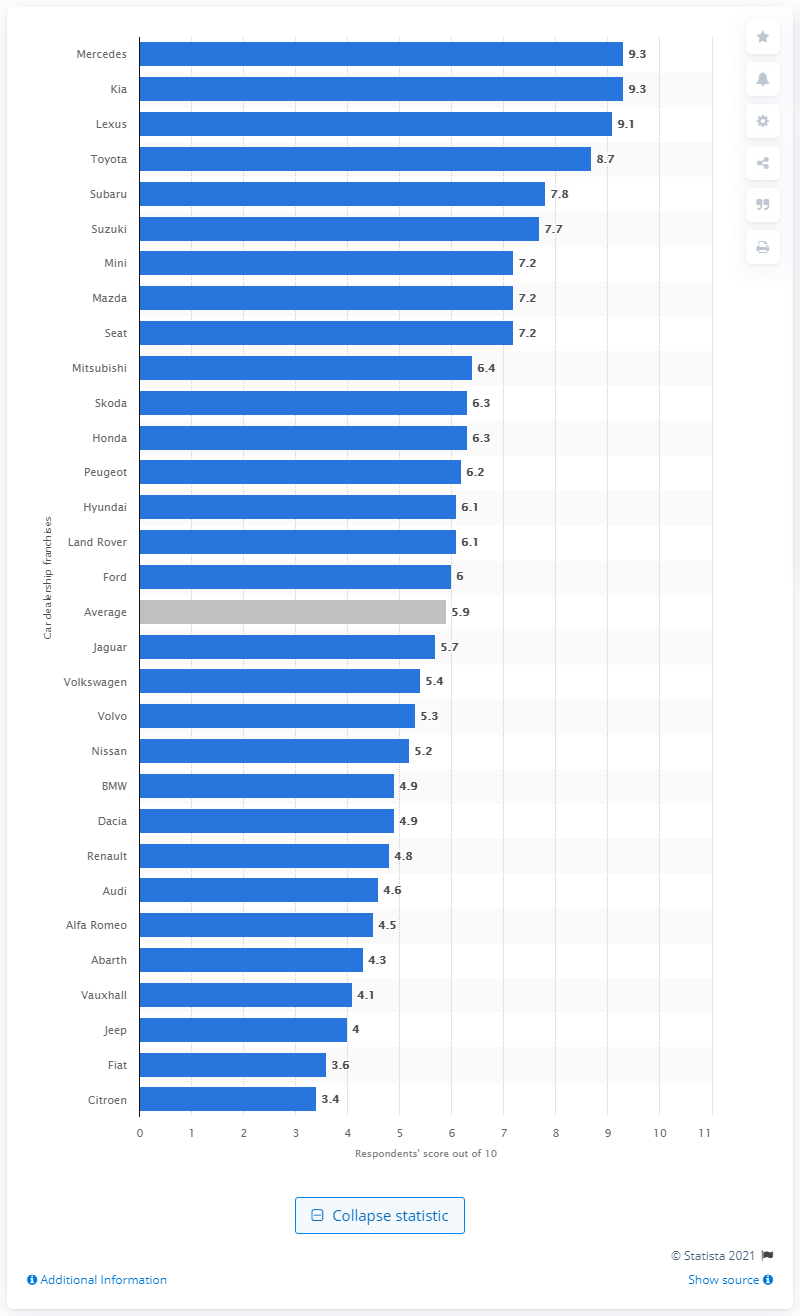Outline some significant characteristics in this image. The highest score given to Mercedes and Kia dealers was 9.3. 